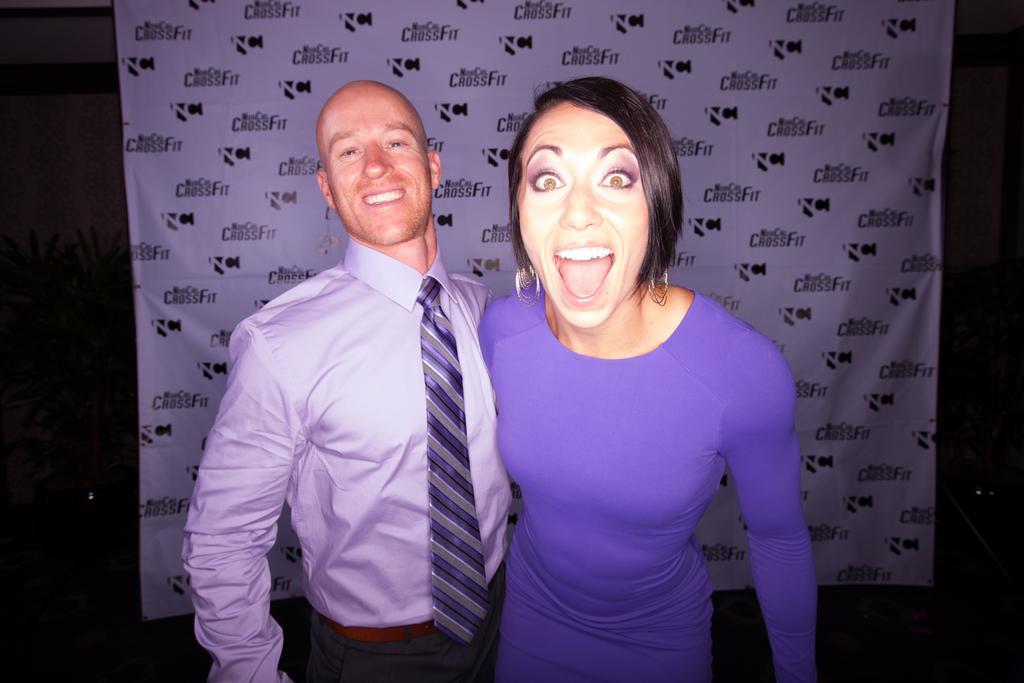Can you describe this image briefly? In this image at front there are two persons standing on the floor. Behind them there is a banner. At the back side there are plants. 